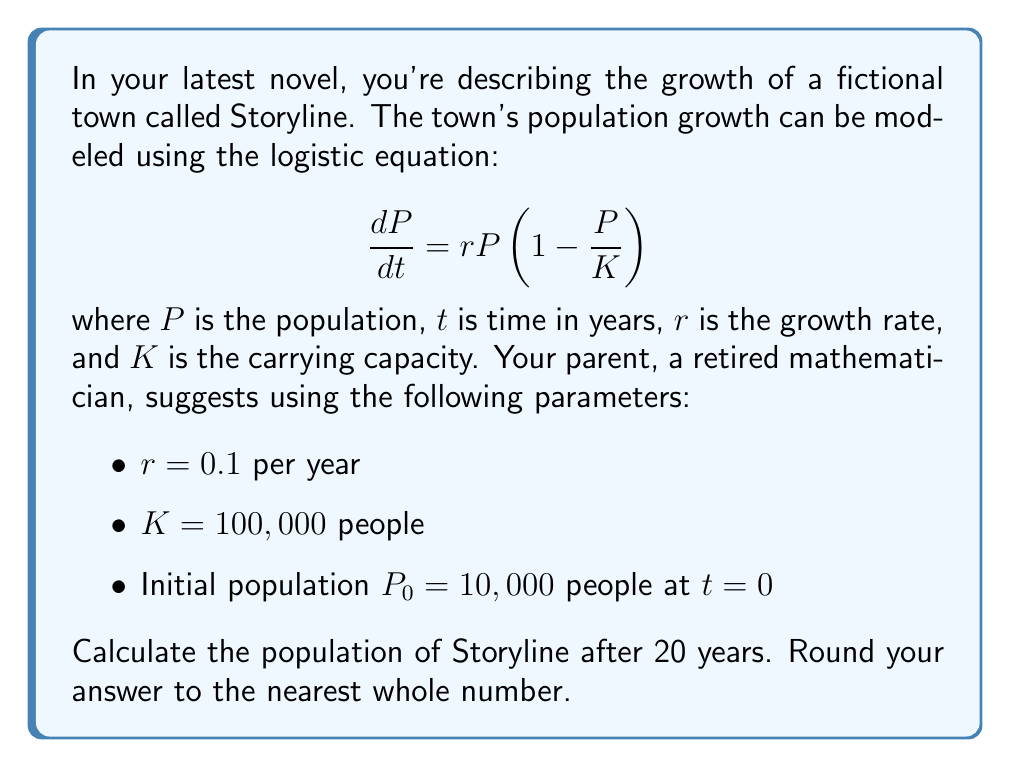Show me your answer to this math problem. Let's approach this step-by-step:

1) The general solution to the logistic equation is:

   $$P(t) = \frac{K}{1 + (\frac{K}{P_0} - 1)e^{-rt}}$$

2) We're given:
   $K = 100,000$
   $P_0 = 10,000$
   $r = 0.1$
   $t = 20$

3) Let's substitute these values into the equation:

   $$P(20) = \frac{100,000}{1 + (\frac{100,000}{10,000} - 1)e^{-0.1(20)}}$$

4) Simplify inside the parentheses:
   
   $$P(20) = \frac{100,000}{1 + (9)e^{-2}}$$

5) Calculate $e^{-2}$:
   
   $$P(20) = \frac{100,000}{1 + 9(0.1353)}$$

6) Multiply:
   
   $$P(20) = \frac{100,000}{1 + 1.2177}$$

7) Add in the denominator:
   
   $$P(20) = \frac{100,000}{2.2177}$$

8) Divide:
   
   $$P(20) = 45,091.76$$

9) Rounding to the nearest whole number:
   
   $$P(20) \approx 45,092$$
Answer: 45,092 people 